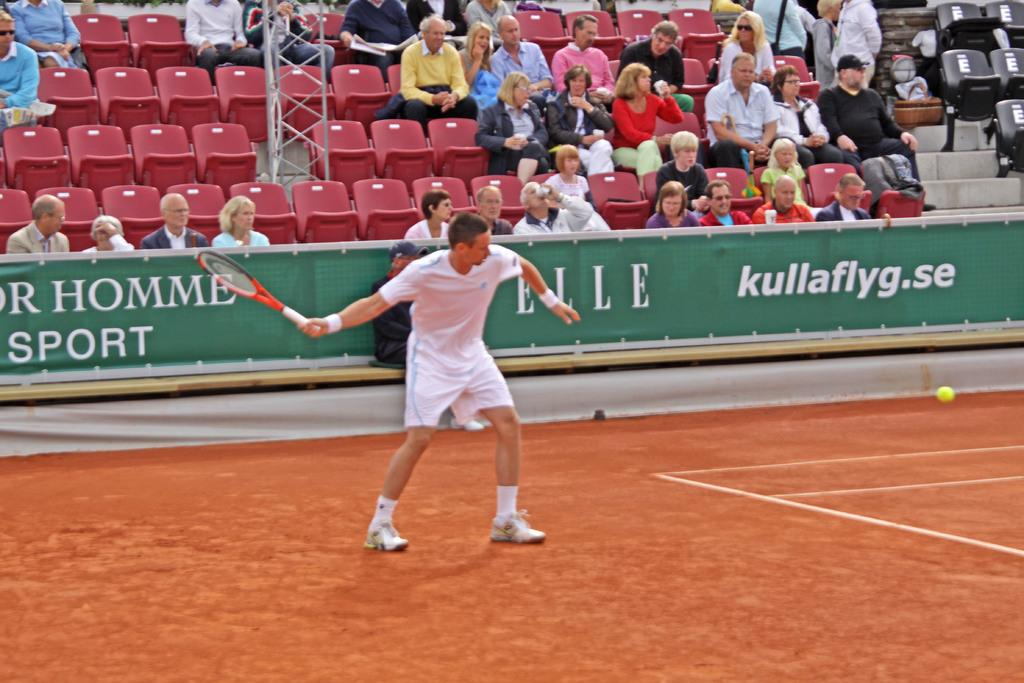What are the people in the image doing? The people in the image are sitting on chairs. What else can be seen in the image besides the people sitting on chairs? There is a banner and a man holding a shuttle bat in the image. What type of jelly is being used to hold up the tent in the image? There is no tent or jelly present in the image. 